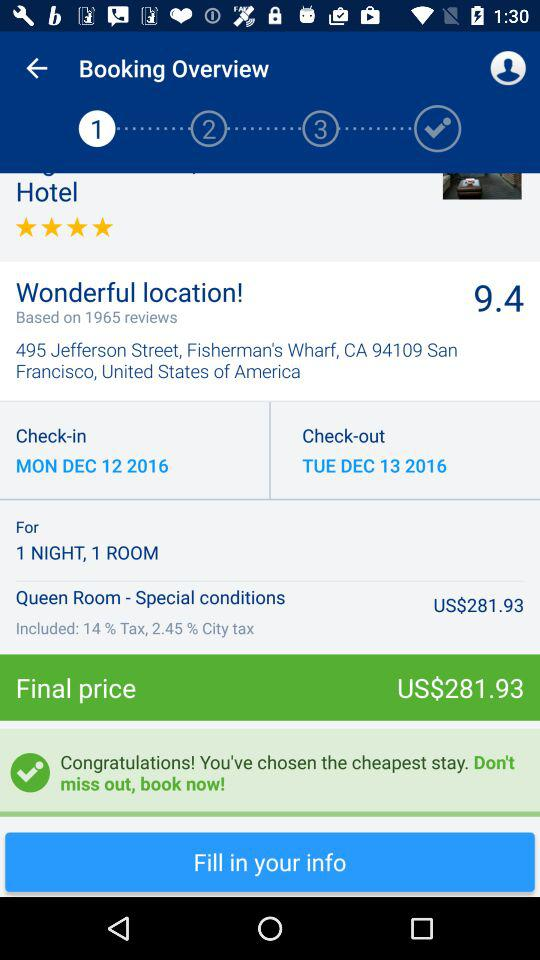What is the location of the hotel? The location of the hotel is 495 Jefferson Street, Fisherman's Wharf, CA 94109, San Francisco, United States of America. 